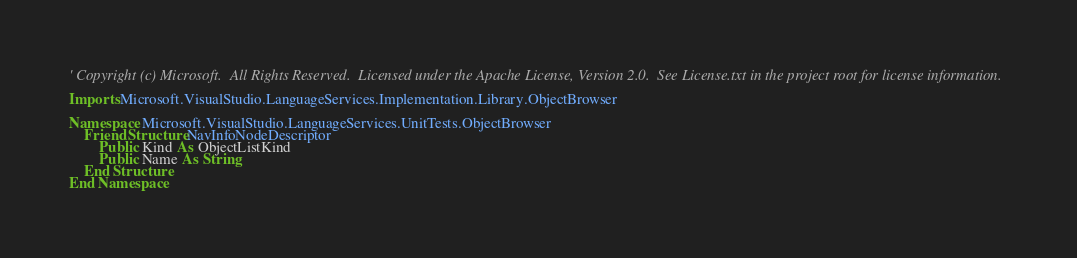<code> <loc_0><loc_0><loc_500><loc_500><_VisualBasic_>' Copyright (c) Microsoft.  All Rights Reserved.  Licensed under the Apache License, Version 2.0.  See License.txt in the project root for license information.

Imports Microsoft.VisualStudio.LanguageServices.Implementation.Library.ObjectBrowser

Namespace Microsoft.VisualStudio.LanguageServices.UnitTests.ObjectBrowser
    Friend Structure NavInfoNodeDescriptor
        Public Kind As ObjectListKind
        Public Name As String
    End Structure
End Namespace
</code> 